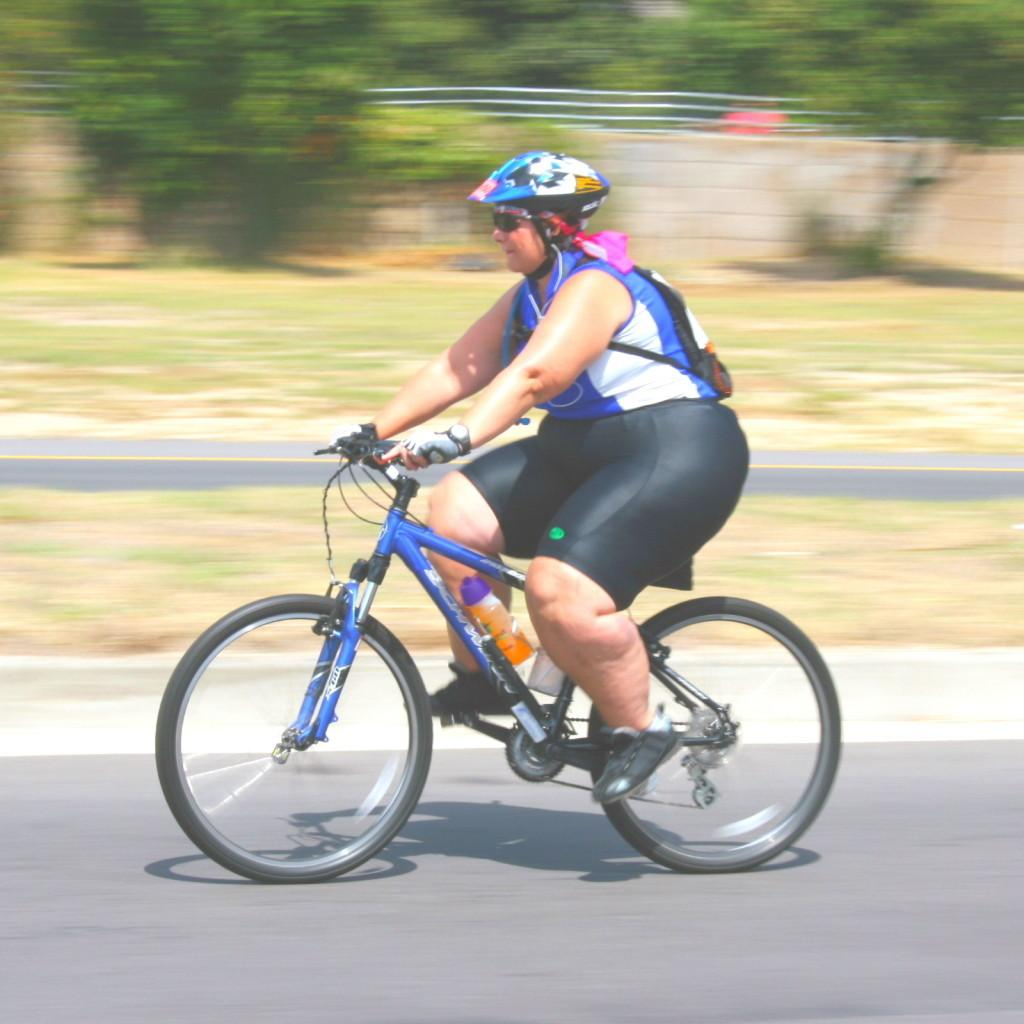What is the person in the image doing? The person is on a cycle. What is the person wearing that provides protection? The person is wearing a helmet. What can be seen in the image besides the person and the cycle? There is a bottle visible in the image. What type of environment is visible in the background of the image? There is grass, a road, and trees in the background of the image. What type of writing can be seen on the helmet in the image? There is no writing visible on the helmet in the image. Is there any snow present in the image? No, there is no snow present in the image; it appears to be a grassy area with trees in the background. 